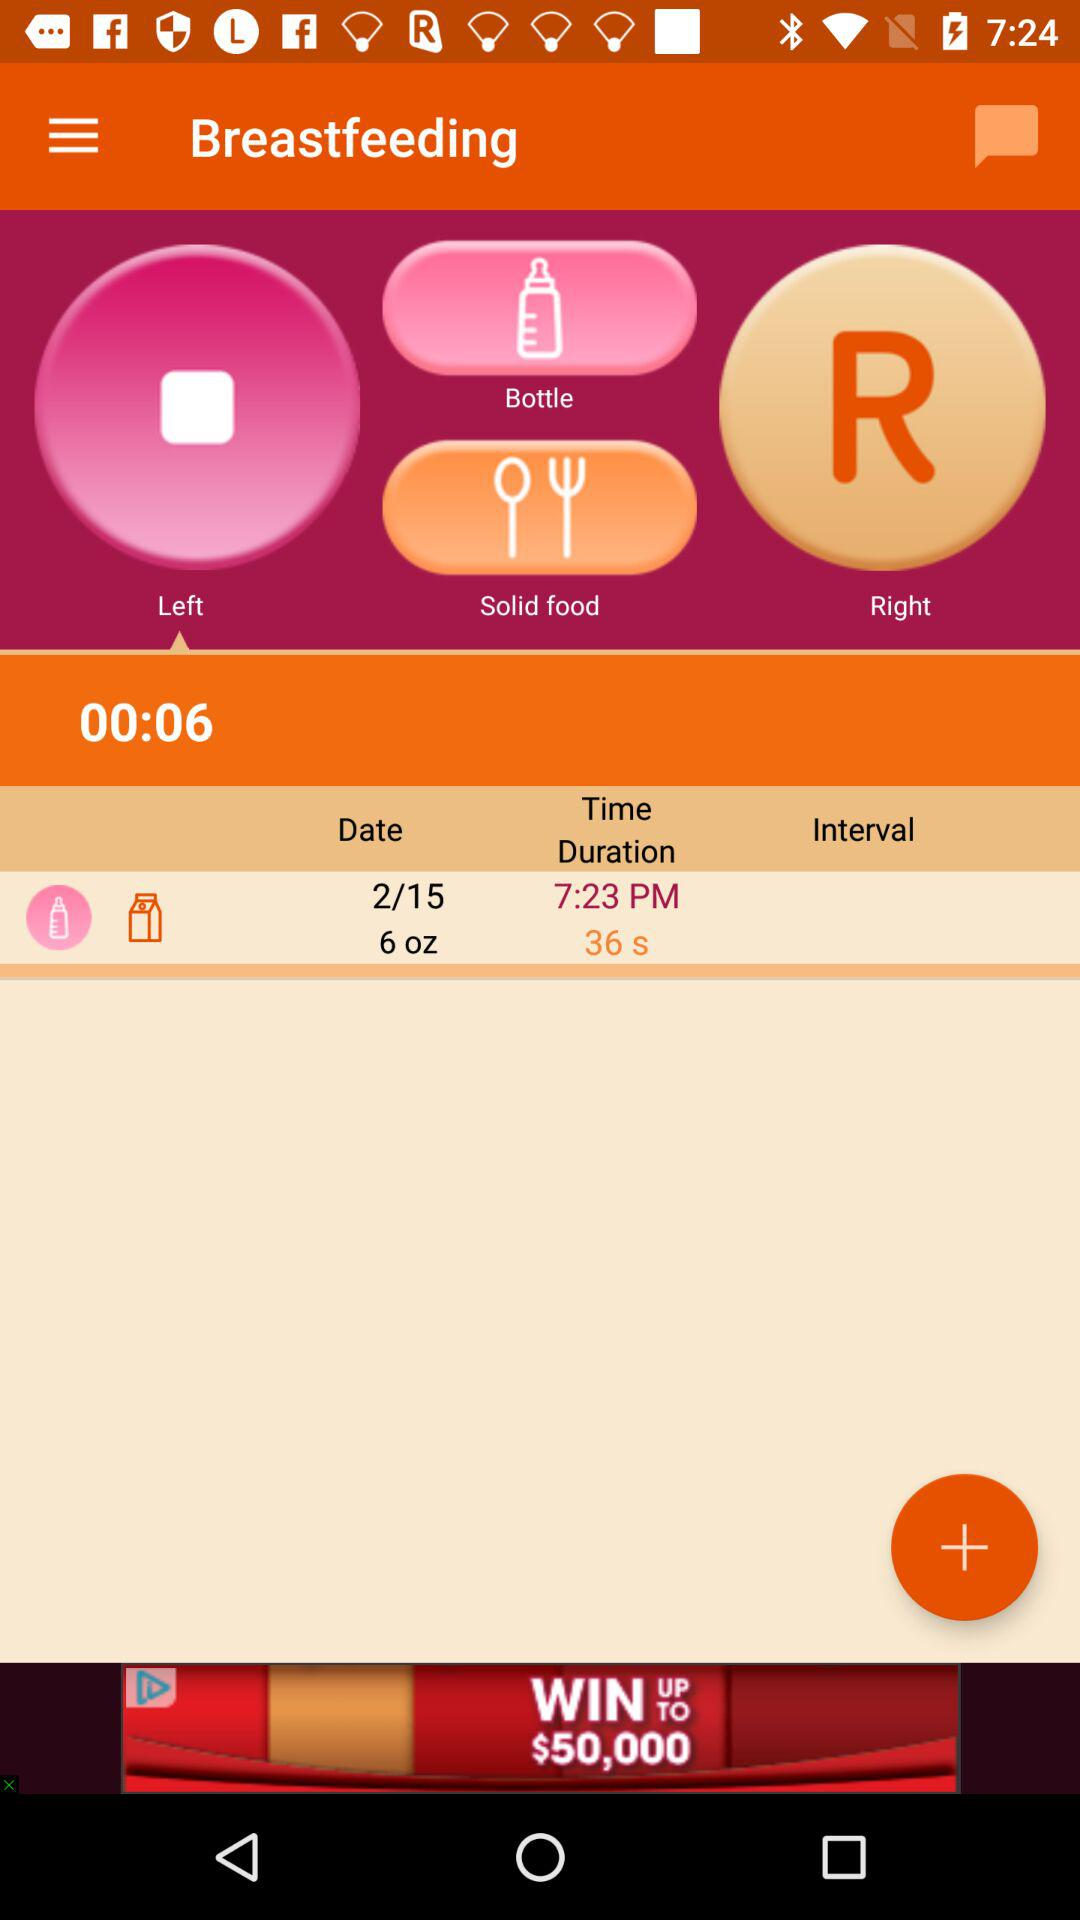What is the time duration of the left breastfeed? The time duration is 00:06. 